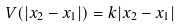Convert formula to latex. <formula><loc_0><loc_0><loc_500><loc_500>V ( | x _ { 2 } - x _ { 1 } | ) = k | x _ { 2 } - x _ { 1 } |</formula> 